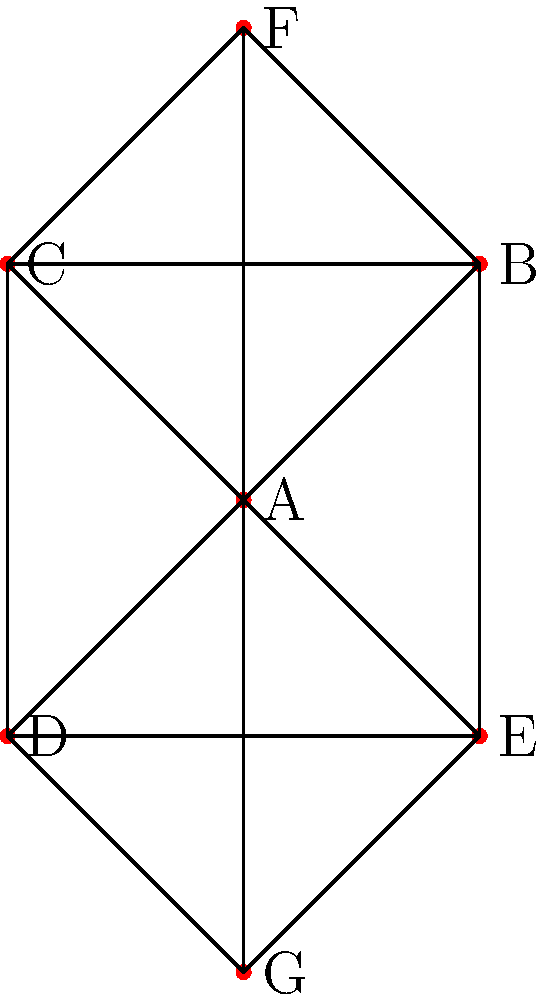In a museum collection network, artworks are represented as nodes, and connections between them (based on style, theme, or artist) are represented as edges. Using the concept of degree centrality in graph theory, which artwork in the given network would be considered the most influential or central to the collection? To determine the most influential artwork using degree centrality, we need to follow these steps:

1. Understand degree centrality: In graph theory, degree centrality is a measure of the number of direct connections a node has to other nodes in the network.

2. Count the connections (degree) for each node:
   A: 6 connections (to B, C, D, E, F, G)
   B: 4 connections (to A, C, E, F)
   C: 4 connections (to A, B, D, F)
   D: 4 connections (to A, C, E, G)
   E: 4 connections (to A, B, D, G)
   F: 3 connections (to A, B, C)
   G: 3 connections (to A, D, E)

3. Identify the node with the highest degree: Node A has the highest degree with 6 connections.

4. Interpret the result: In the context of an art collection, the artwork represented by node A has the most connections to other pieces in the collection. This suggests that it shares the most similarities in style, theme, or artist with other works, making it central to understanding the collection as a whole.

5. Relate to van Gogh's work: As an admirer of van Gogh, you might imagine this central artwork as one of his pivotal pieces, such as "The Starry Night" or "Sunflowers," which have had a significant influence on other artists and are often connected thematically or stylistically to many other works in a museum's collection.
Answer: Artwork A 